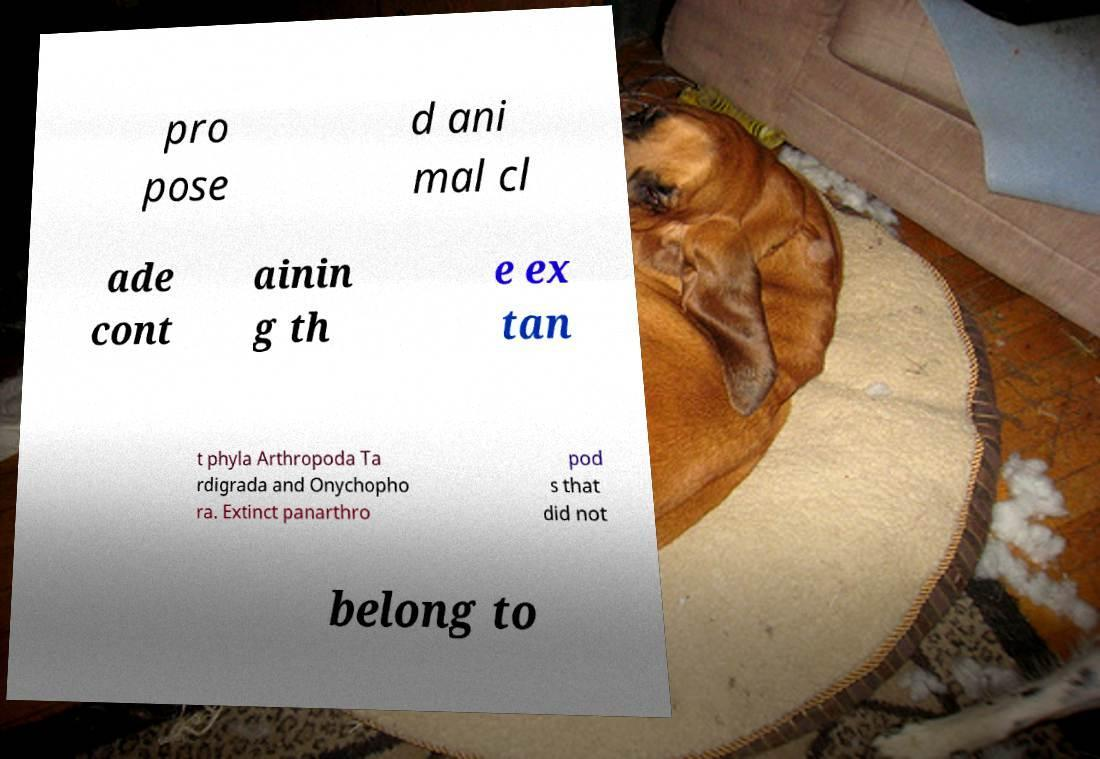Please read and relay the text visible in this image. What does it say? pro pose d ani mal cl ade cont ainin g th e ex tan t phyla Arthropoda Ta rdigrada and Onychopho ra. Extinct panarthro pod s that did not belong to 